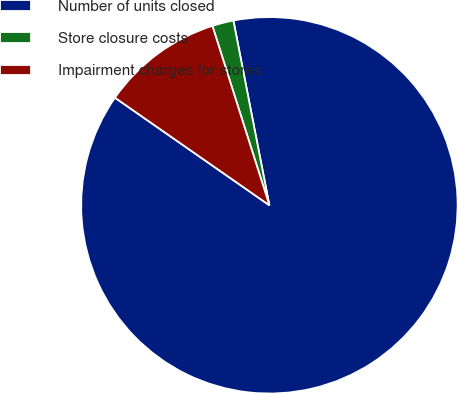Convert chart. <chart><loc_0><loc_0><loc_500><loc_500><pie_chart><fcel>Number of units closed<fcel>Store closure costs<fcel>Impairment charges for stores<nl><fcel>87.74%<fcel>1.83%<fcel>10.42%<nl></chart> 